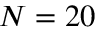Convert formula to latex. <formula><loc_0><loc_0><loc_500><loc_500>N = 2 0</formula> 